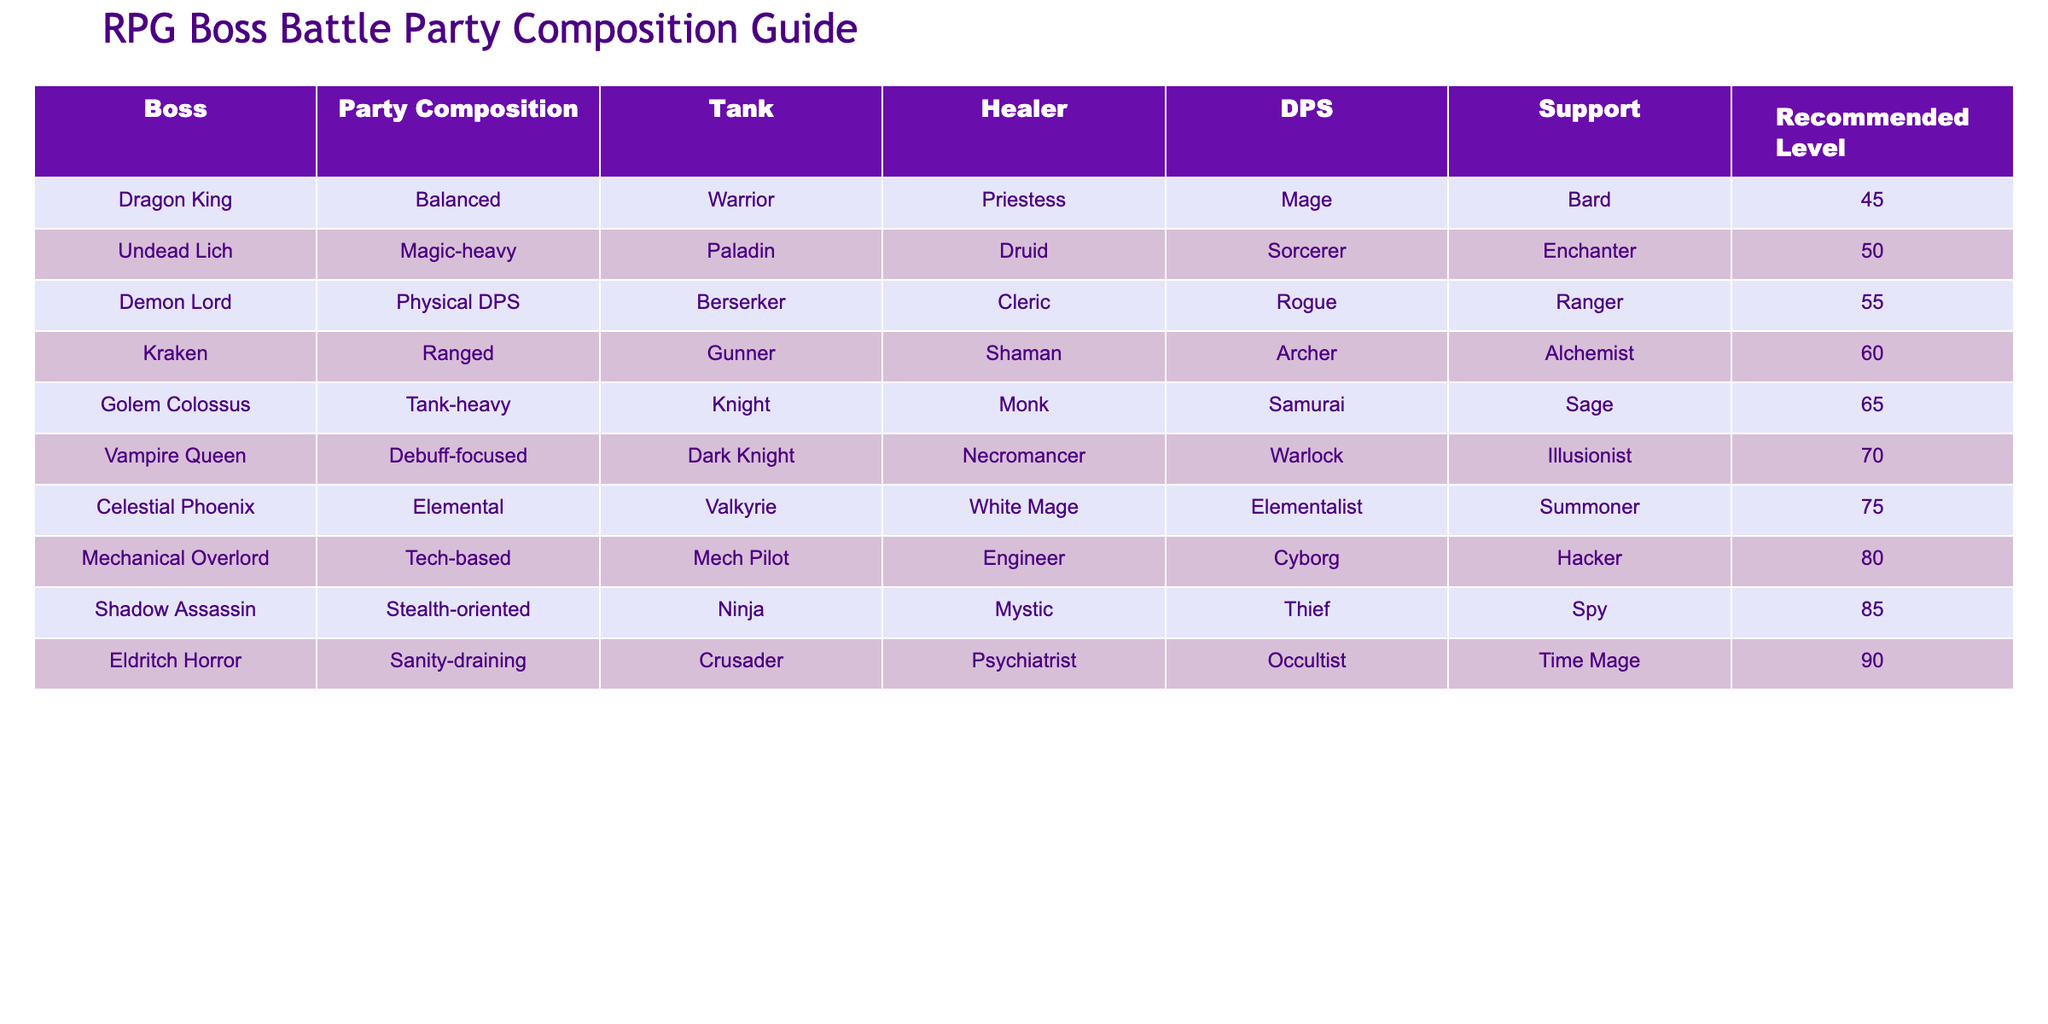What is the party composition recommended for the Dragon King? According to the table, the recommended party composition for the Dragon King consists of a Warrior as the Tank, a Priestess as the Healer, a Mage as the DPS (damage per second), and a Bard as the Support.
Answer: Balanced Which boss requires a higher recommended level: the Demon Lord or the Kraken? The recommended level for the Demon Lord is 55, while the Kraken has a recommended level of 60. Since 60 is higher than 55, the Kraken requires a higher recommended level than the Demon Lord.
Answer: Kraken Is there a party composition focused on debuffs? Yes, the party composition for the Vampire Queen is explicitly noted as Debuff-focused, consisting of a Dark Knight tank, a Necromancer healer, a Warlock DPS, and an Illusionist as support.
Answer: Yes What is the average recommended level of all bosses listed in the table? To find the average recommended level, first, we sum the recommended levels: 45 + 50 + 55 + 60 + 65 + 70 + 75 + 80 + 85 + 90 = 755. Then, we divide by the total number of bosses, which is 10: 755 / 10 = 75.5.
Answer: 75.5 Which boss has a party composition that includes a Cybernetic character? The Mechanical Overlord has a party composition that includes a Cyborg in the DPS role, supported by a Mech Pilot tank, an Engineer healer, and a Hacker support.
Answer: Mechanical Overlord 